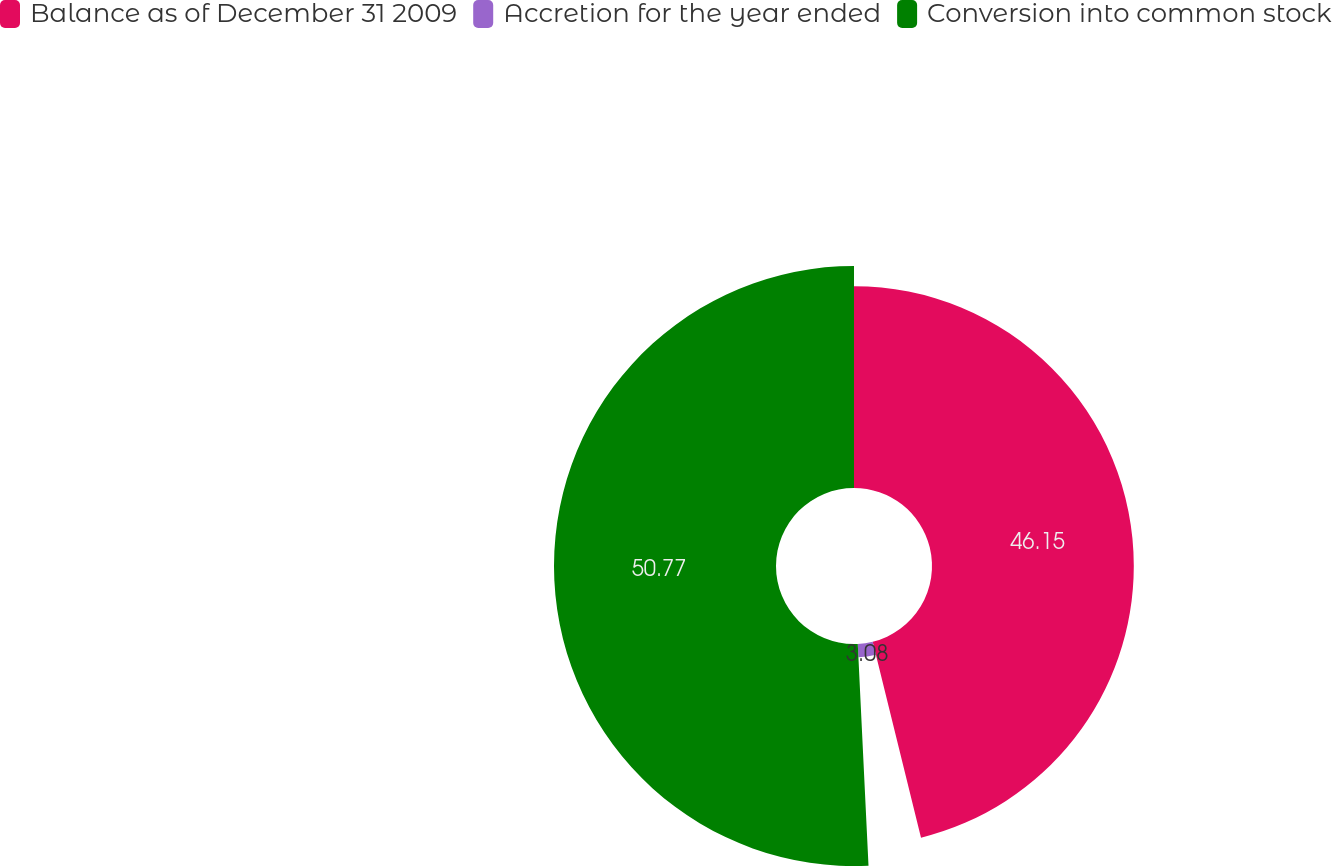<chart> <loc_0><loc_0><loc_500><loc_500><pie_chart><fcel>Balance as of December 31 2009<fcel>Accretion for the year ended<fcel>Conversion into common stock<nl><fcel>46.15%<fcel>3.08%<fcel>50.77%<nl></chart> 